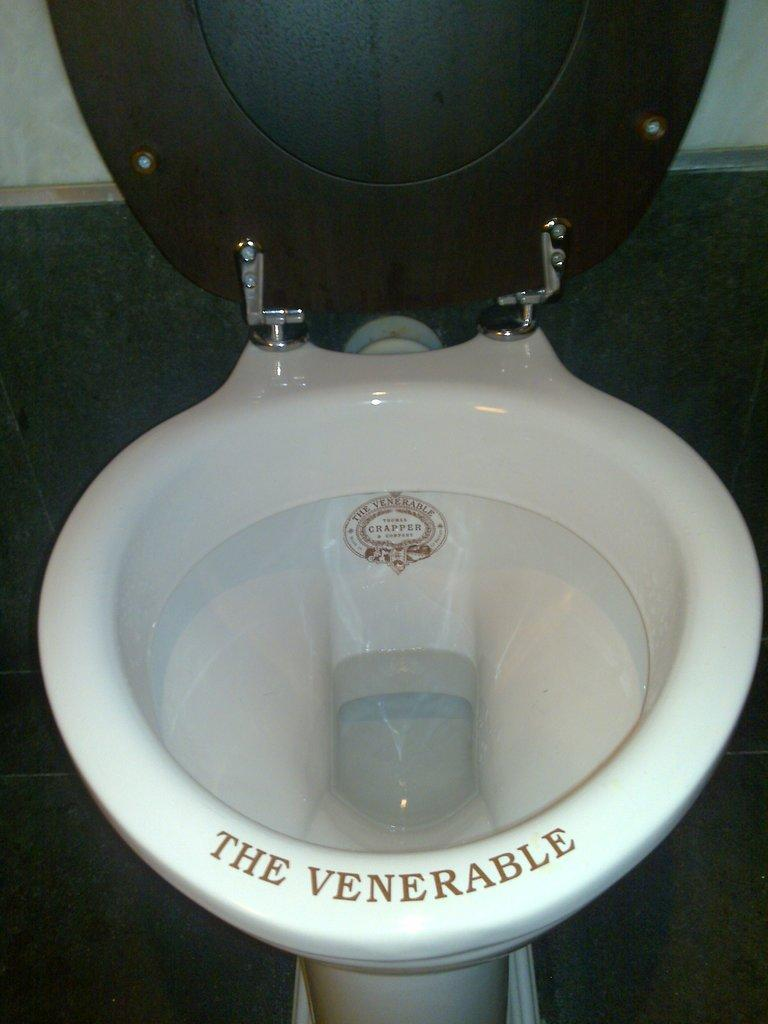<image>
Relay a brief, clear account of the picture shown. A toilet bowl that says The Venerable on the porcelain rim. 